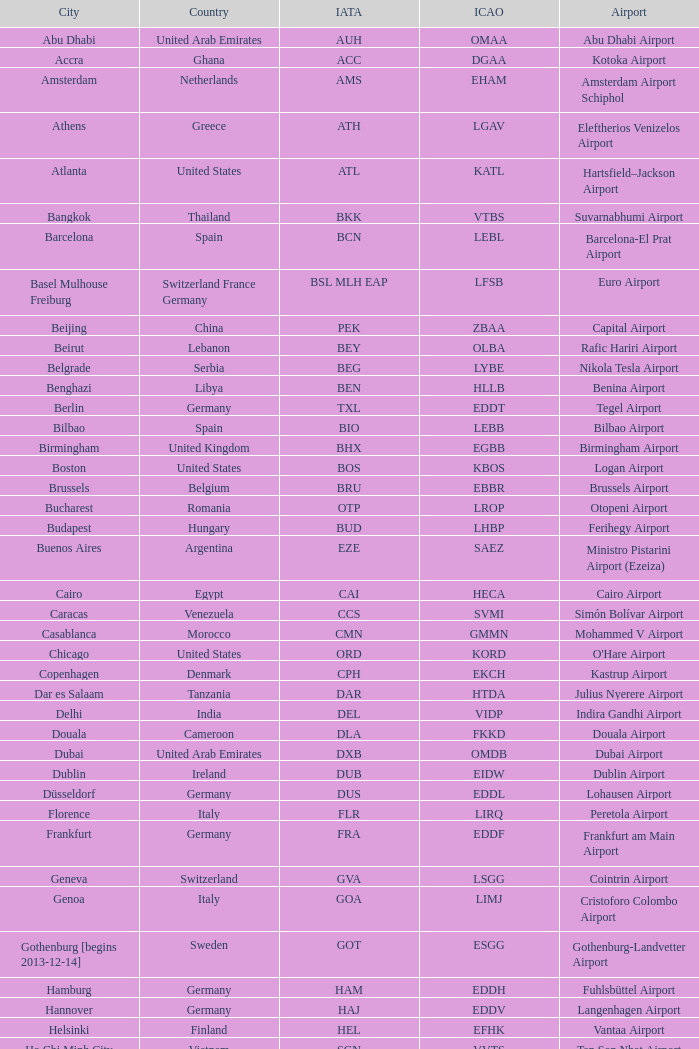What is the ICAO of Douala city? FKKD. 